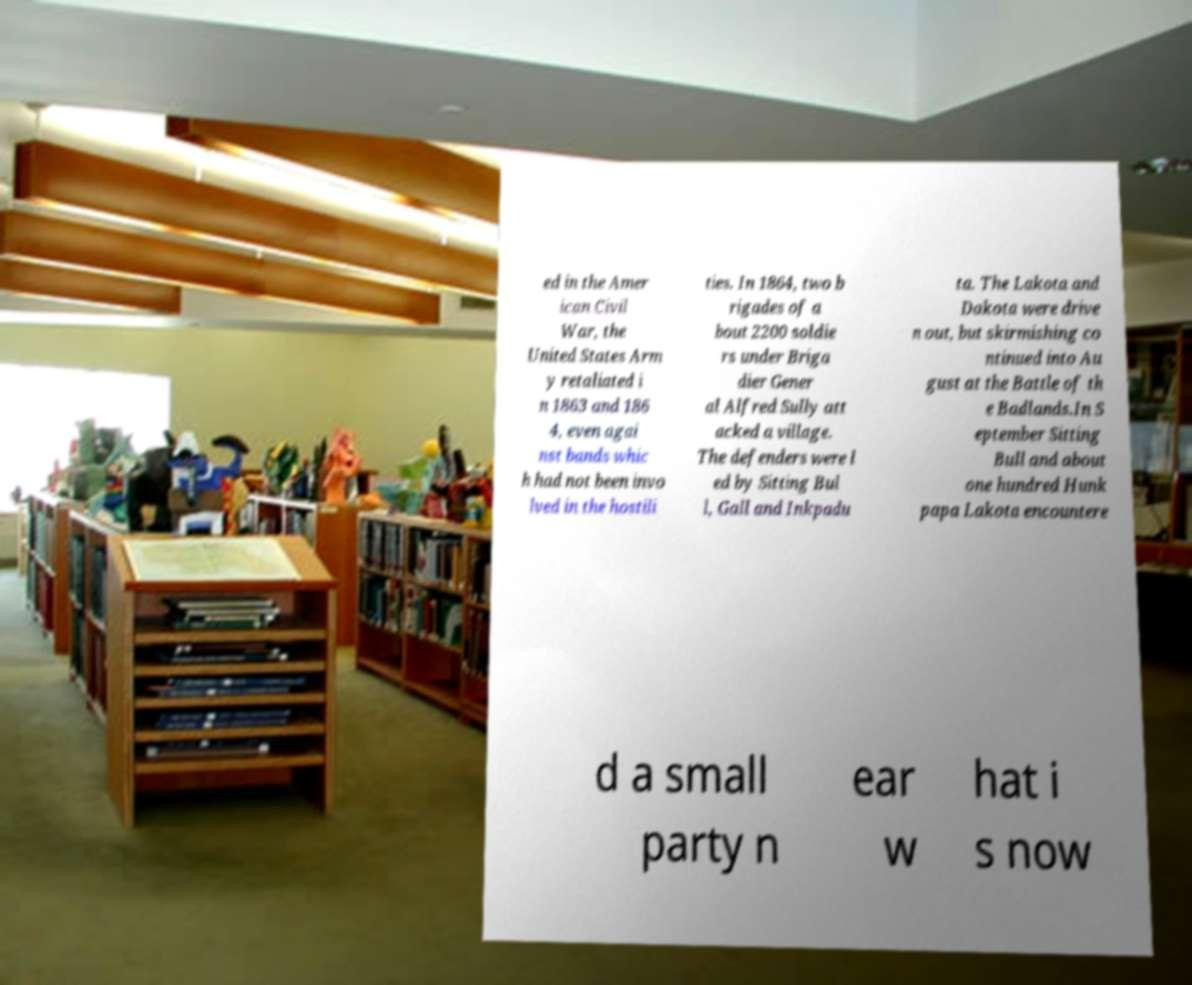There's text embedded in this image that I need extracted. Can you transcribe it verbatim? ed in the Amer ican Civil War, the United States Arm y retaliated i n 1863 and 186 4, even agai nst bands whic h had not been invo lved in the hostili ties. In 1864, two b rigades of a bout 2200 soldie rs under Briga dier Gener al Alfred Sully att acked a village. The defenders were l ed by Sitting Bul l, Gall and Inkpadu ta. The Lakota and Dakota were drive n out, but skirmishing co ntinued into Au gust at the Battle of th e Badlands.In S eptember Sitting Bull and about one hundred Hunk papa Lakota encountere d a small party n ear w hat i s now 